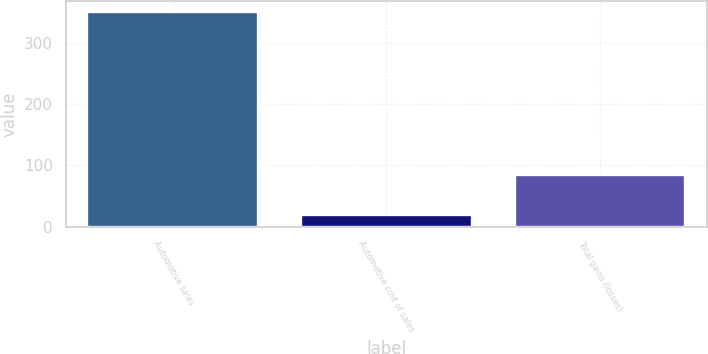Convert chart. <chart><loc_0><loc_0><loc_500><loc_500><bar_chart><fcel>Automotive sales<fcel>Automotive cost of sales<fcel>Total gains (losses)<nl><fcel>351<fcel>19<fcel>85<nl></chart> 